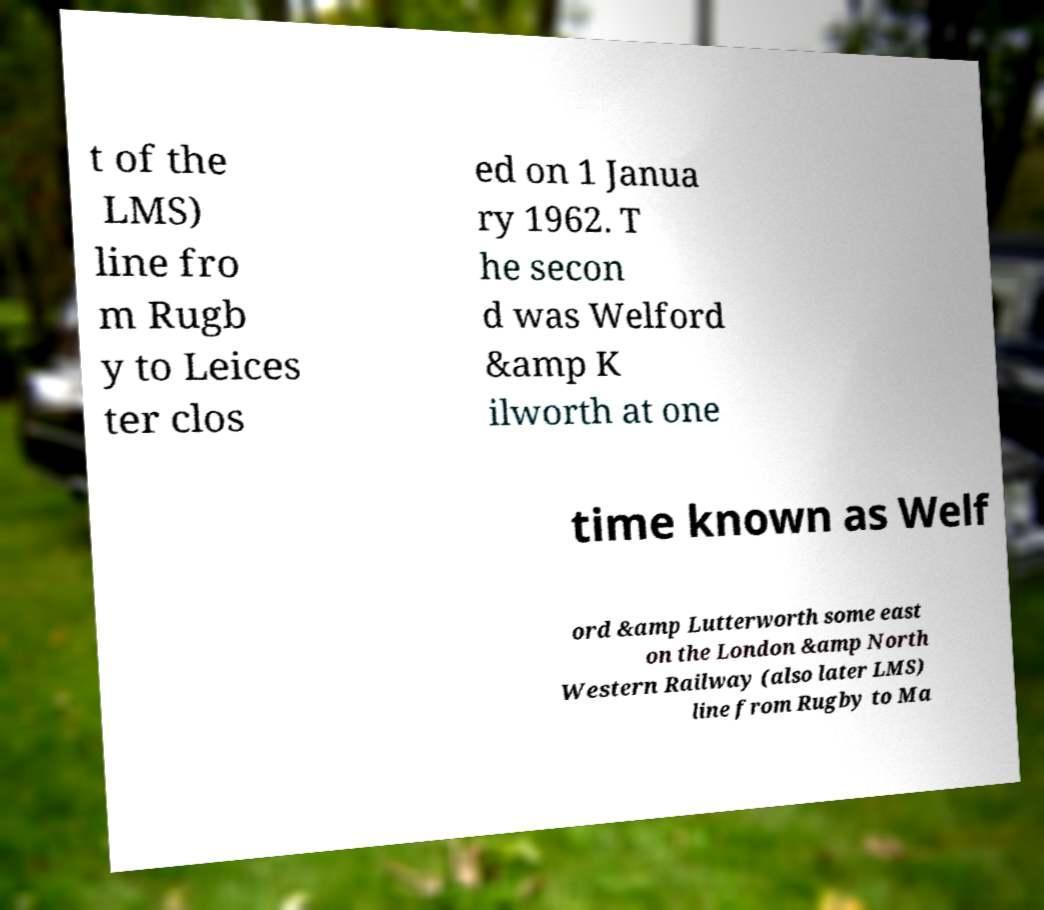What messages or text are displayed in this image? I need them in a readable, typed format. t of the LMS) line fro m Rugb y to Leices ter clos ed on 1 Janua ry 1962. T he secon d was Welford &amp K ilworth at one time known as Welf ord &amp Lutterworth some east on the London &amp North Western Railway (also later LMS) line from Rugby to Ma 